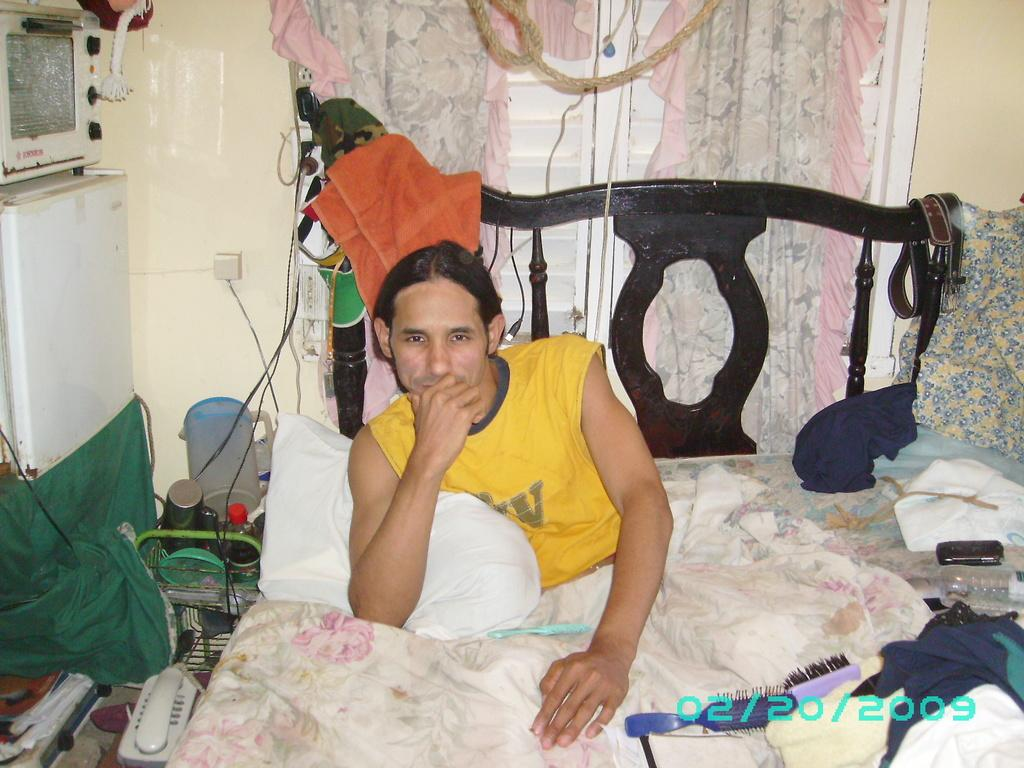What is the person in the image doing? There is a person sitting on the bed in the image. What communication device can be seen in the image? There is a telephone in the image. What type of container is present in the image? There is a bottle in the image. What grooming tools are visible in the image? There are combs in the image. What type of window treatment is present in the image? There are curtains in the image. Where is the text located in the image? The text is written on the left side at the bottom of the image. What type of police equipment can be seen in the image? There is no police equipment present in the image. Is there a cellar visible in the image? There is no cellar present in the image. 